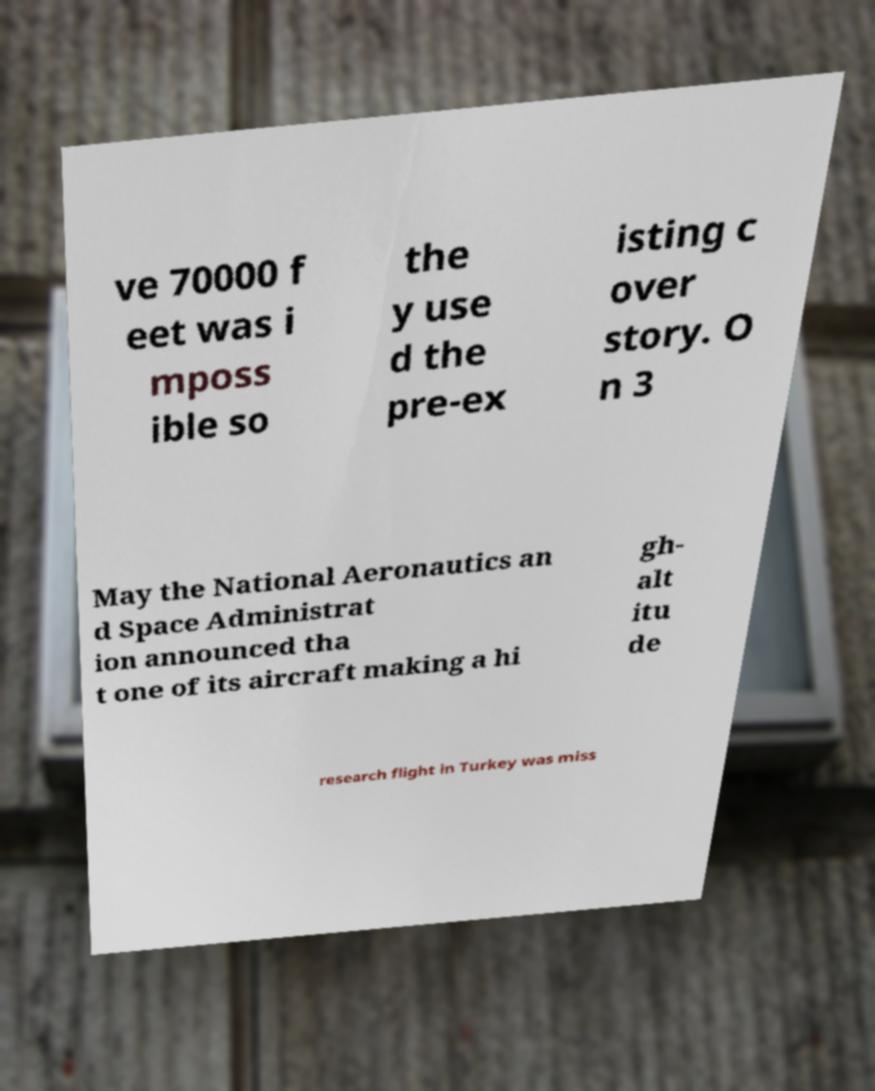Please read and relay the text visible in this image. What does it say? ve 70000 f eet was i mposs ible so the y use d the pre-ex isting c over story. O n 3 May the National Aeronautics an d Space Administrat ion announced tha t one of its aircraft making a hi gh- alt itu de research flight in Turkey was miss 